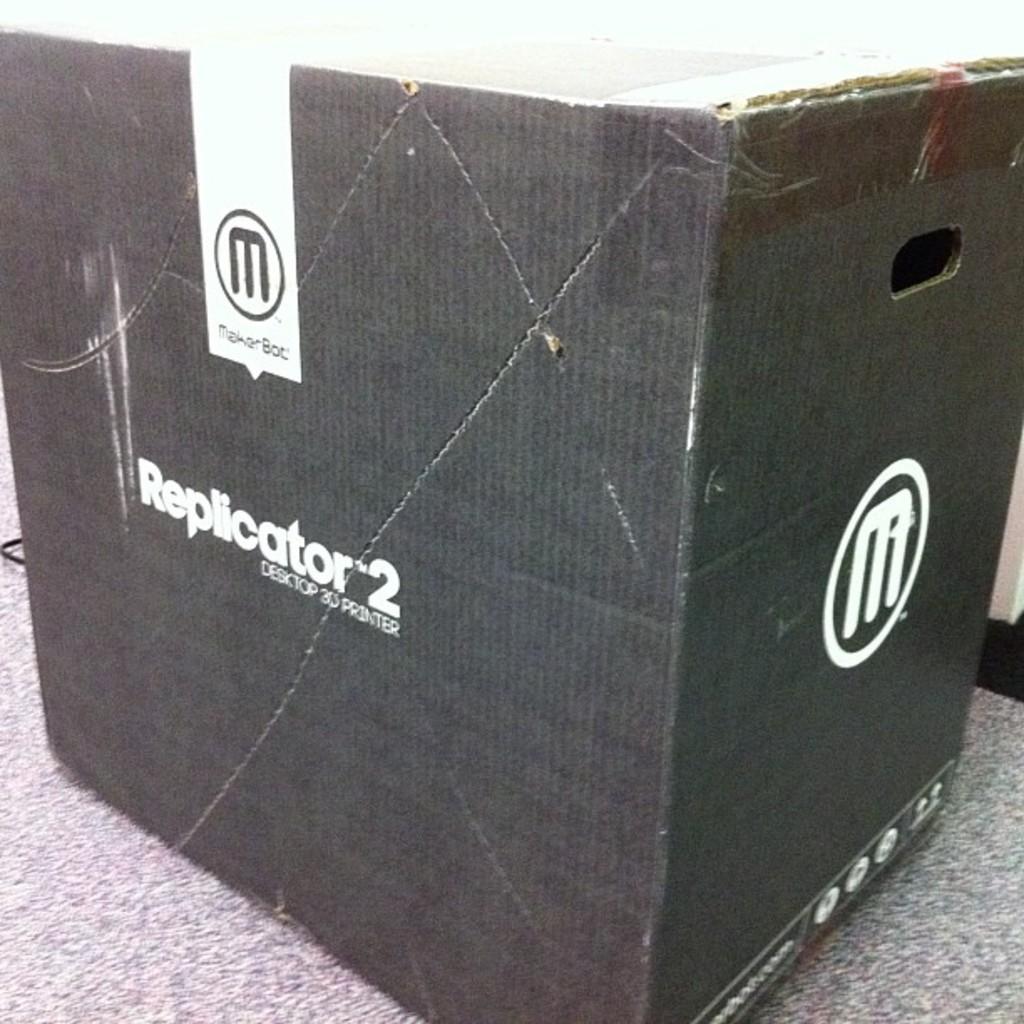Describe this image in one or two sentences. In the center of the image we can see a cardboard box placed on the floor. 